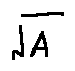<formula> <loc_0><loc_0><loc_500><loc_500>\sqrt { A }</formula> 